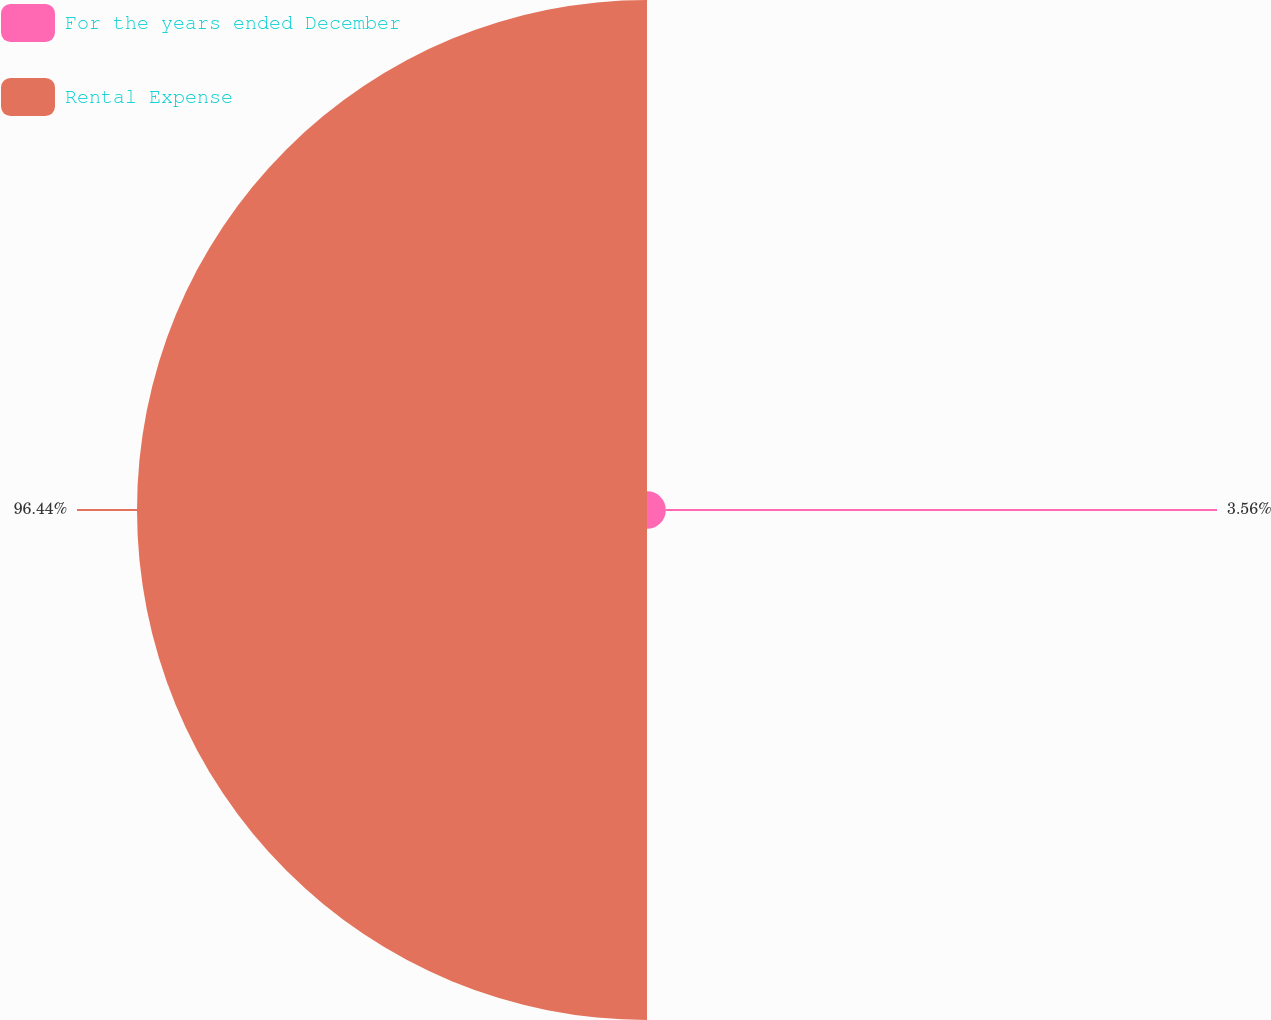<chart> <loc_0><loc_0><loc_500><loc_500><pie_chart><fcel>For the years ended December<fcel>Rental Expense<nl><fcel>3.56%<fcel>96.44%<nl></chart> 